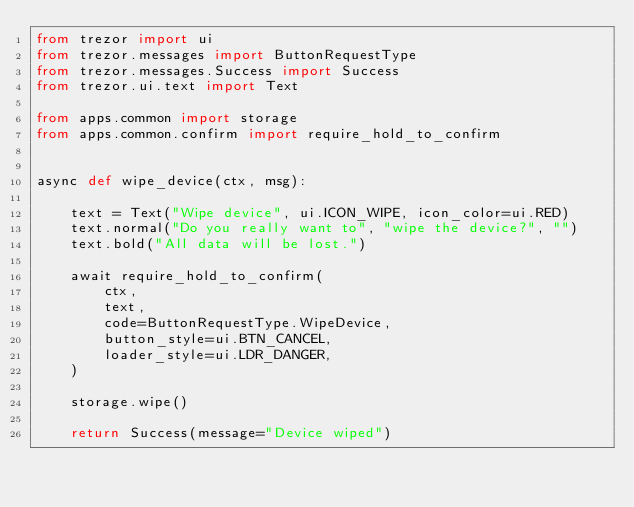Convert code to text. <code><loc_0><loc_0><loc_500><loc_500><_Python_>from trezor import ui
from trezor.messages import ButtonRequestType
from trezor.messages.Success import Success
from trezor.ui.text import Text

from apps.common import storage
from apps.common.confirm import require_hold_to_confirm


async def wipe_device(ctx, msg):

    text = Text("Wipe device", ui.ICON_WIPE, icon_color=ui.RED)
    text.normal("Do you really want to", "wipe the device?", "")
    text.bold("All data will be lost.")

    await require_hold_to_confirm(
        ctx,
        text,
        code=ButtonRequestType.WipeDevice,
        button_style=ui.BTN_CANCEL,
        loader_style=ui.LDR_DANGER,
    )

    storage.wipe()

    return Success(message="Device wiped")
</code> 